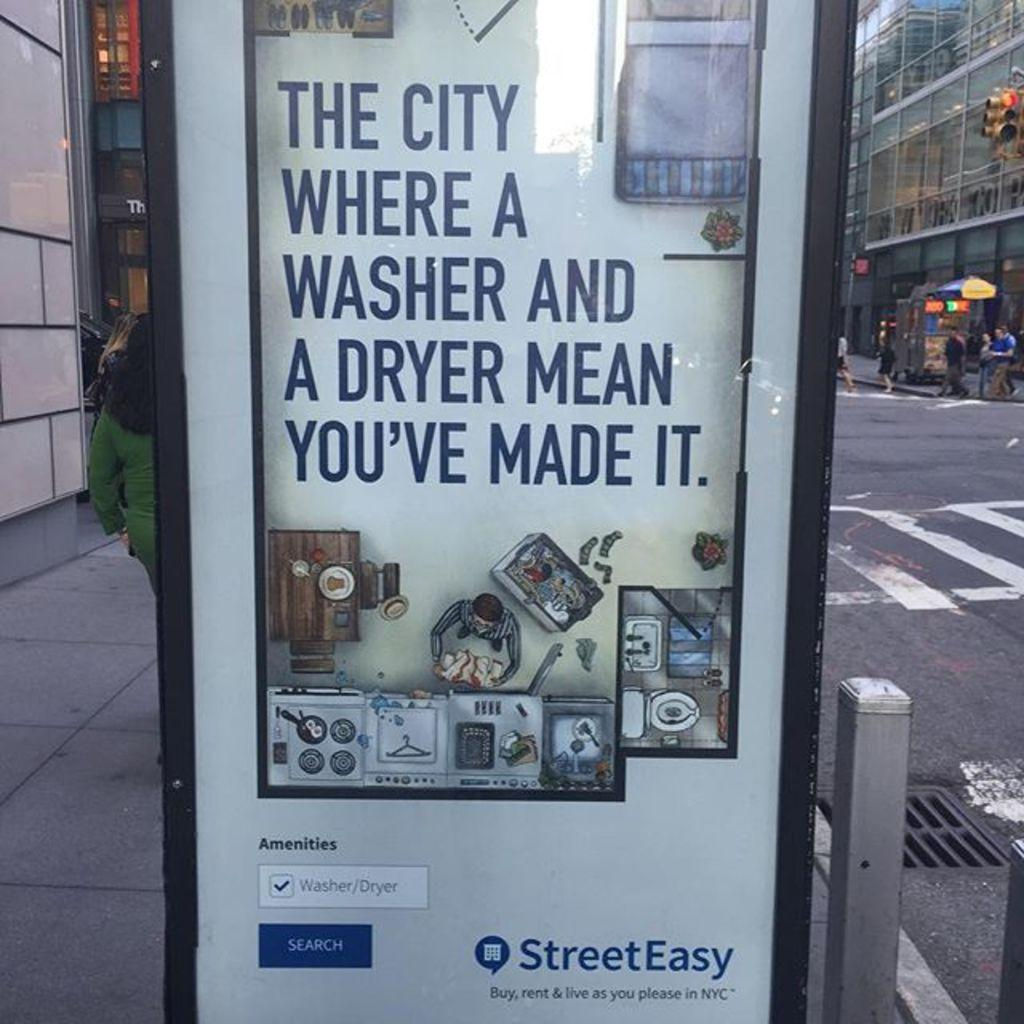Provide a one-sentence caption for the provided image. A banner advertisement for StreetEasy app that aids buying or renting housing amenities in NYC. 